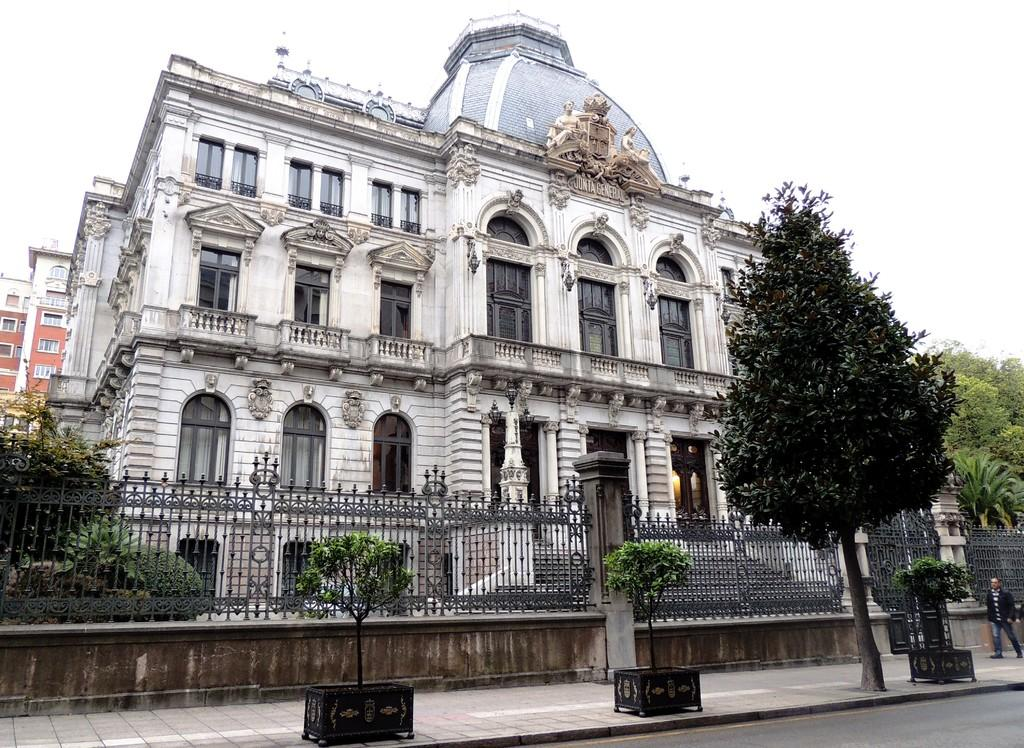What type of structures can be seen in the image? There are buildings in the image. What is the barrier surrounding the area in the image? There is a fence in the image. What type of vegetation is present in the image? There are plants and trees in the image. What type of pathway is visible in the image? There is a road in the image. What type of artwork can be seen in the image? There are sculptures in the image. Are there any people present in the image? Yes, there is a person in the image. What can be seen in the background of the image? The sky is visible in the background of the image. What type of quiver is the person holding in the image? There is no quiver present in the image; the person is not holding any such object. What type of chin can be seen on the sculpture in the image? There is no chin visible on any sculpture in the image, as the sculptures do not have human-like facial features. 